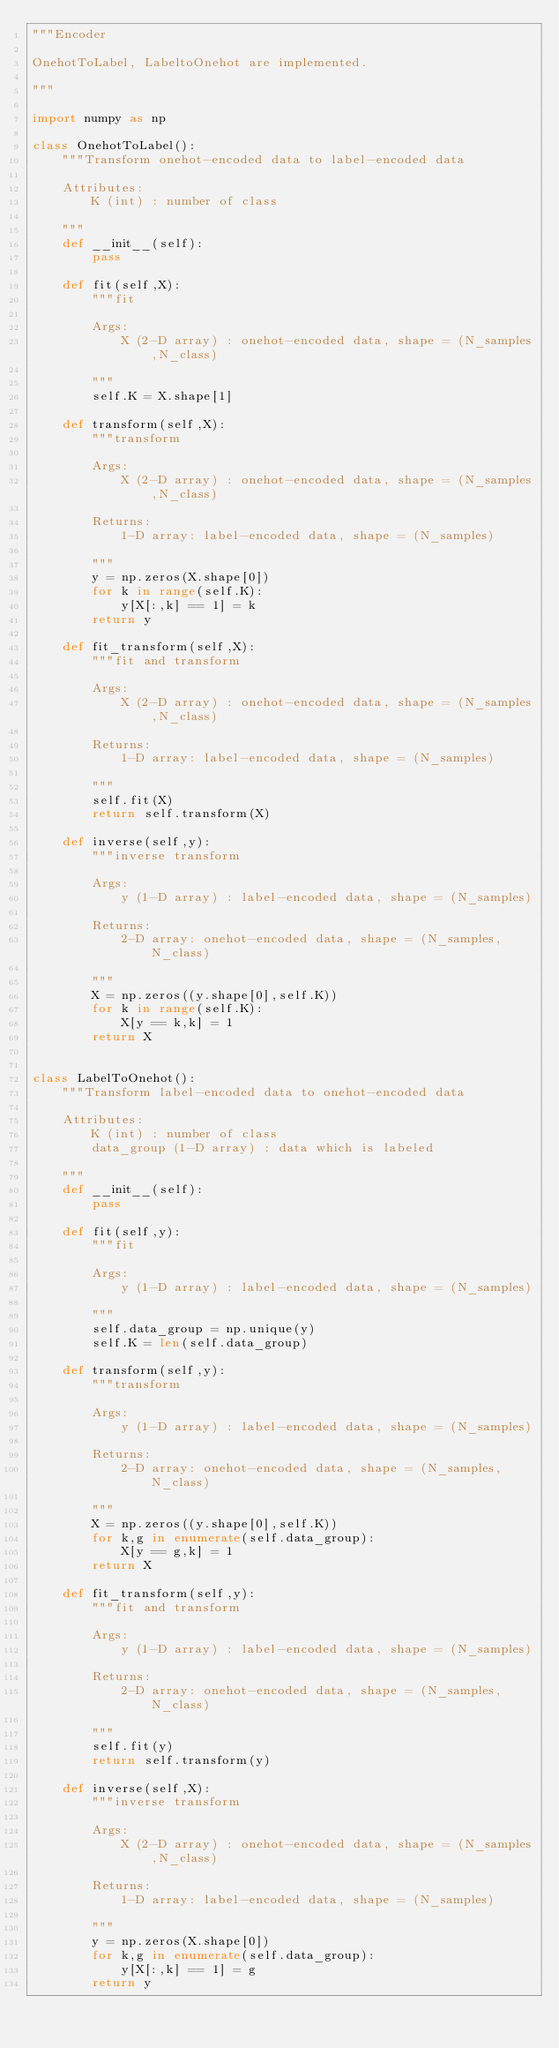Convert code to text. <code><loc_0><loc_0><loc_500><loc_500><_Python_>"""Encoder 

OnehotToLabel, LabeltoOnehot are implemented.

"""

import numpy as np 

class OnehotToLabel():
    """Transform onehot-encoded data to label-encoded data

    Attributes:
        K (int) : number of class 

    """
    def __init__(self):
        pass 

    def fit(self,X):
        """fit

        Args:
            X (2-D array) : onehot-encoded data, shape = (N_samples,N_class) 

        """
        self.K = X.shape[1] 

    def transform(self,X):
        """transform 

        Args:
            X (2-D array) : onehot-encoded data, shape = (N_samples,N_class) 

        Returns:
            1-D array: label-encoded data, shape = (N_samples)

        """
        y = np.zeros(X.shape[0])
        for k in range(self.K): 
            y[X[:,k] == 1] = k 
        return y 

    def fit_transform(self,X):
        """fit and transform 

        Args:
            X (2-D array) : onehot-encoded data, shape = (N_samples,N_class) 

        Returns:
            1-D array: label-encoded data, shape = (N_samples)

        """
        self.fit(X)
        return self.transform(X) 

    def inverse(self,y): 
        """inverse transform 

        Args:
            y (1-D array) : label-encoded data, shape = (N_samples) 

        Returns:
            2-D array: onehot-encoded data, shape = (N_samples,N_class)

        """
        X = np.zeros((y.shape[0],self.K)) 
        for k in range(self.K):
            X[y == k,k] = 1 
        return X  


class LabelToOnehot(): 
    """Transform label-encoded data to onehot-encoded data

    Attributes:
        K (int) : number of class 
        data_group (1-D array) : data which is labeled 

    """
    def __init__(self):
        pass 

    def fit(self,y):
        """fit

        Args:
            y (1-D array) : label-encoded data, shape = (N_samples) 

        """
        self.data_group = np.unique(y)  
        self.K = len(self.data_group)
    
    def transform(self,y):
        """transform 

        Args:
            y (1-D array) : label-encoded data, shape = (N_samples) 

        Returns:
            2-D array: onehot-encoded data, shape = (N_samples,N_class)

        """
        X = np.zeros((y.shape[0],self.K)) 
        for k,g in enumerate(self.data_group):
            X[y == g,k] = 1 
        return X  

    def fit_transform(self,y):
        """fit and transform 

        Args:
            y (1-D array) : label-encoded data, shape = (N_samples) 

        Returns:
            2-D array: onehot-encoded data, shape = (N_samples,N_class)

        """
        self.fit(y)
        return self.transform(y) 

    def inverse(self,X): 
        """inverse transform 

        Args:
            X (2-D array) : onehot-encoded data, shape = (N_samples,N_class) 

        Returns:
            1-D array: label-encoded data, shape = (N_samples)
            
        """
        y = np.zeros(X.shape[0])
        for k,g in enumerate(self.data_group): 
            y[X[:,k] == 1] = g 
        return y </code> 